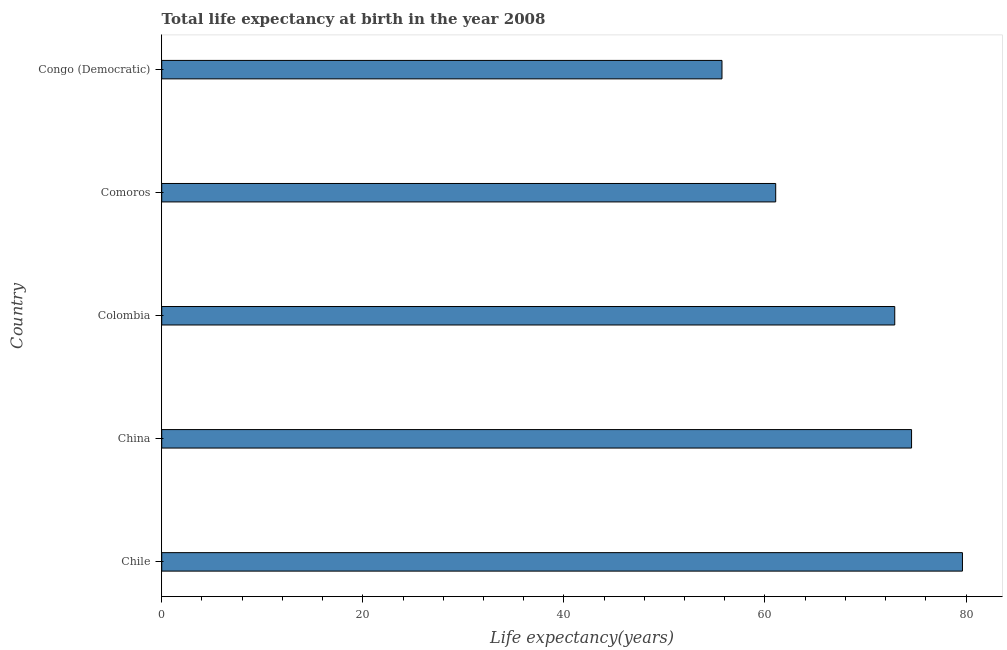What is the title of the graph?
Your response must be concise. Total life expectancy at birth in the year 2008. What is the label or title of the X-axis?
Make the answer very short. Life expectancy(years). What is the life expectancy at birth in Chile?
Keep it short and to the point. 79.64. Across all countries, what is the maximum life expectancy at birth?
Your answer should be compact. 79.64. Across all countries, what is the minimum life expectancy at birth?
Offer a terse response. 55.72. In which country was the life expectancy at birth maximum?
Your answer should be very brief. Chile. In which country was the life expectancy at birth minimum?
Your response must be concise. Congo (Democratic). What is the sum of the life expectancy at birth?
Provide a succinct answer. 343.92. What is the difference between the life expectancy at birth in China and Colombia?
Offer a very short reply. 1.67. What is the average life expectancy at birth per country?
Make the answer very short. 68.78. What is the median life expectancy at birth?
Provide a short and direct response. 72.91. In how many countries, is the life expectancy at birth greater than 68 years?
Offer a very short reply. 3. What is the ratio of the life expectancy at birth in Chile to that in Comoros?
Provide a short and direct response. 1.3. Is the difference between the life expectancy at birth in Colombia and Congo (Democratic) greater than the difference between any two countries?
Offer a terse response. No. What is the difference between the highest and the second highest life expectancy at birth?
Your answer should be compact. 5.06. What is the difference between the highest and the lowest life expectancy at birth?
Make the answer very short. 23.92. How many bars are there?
Ensure brevity in your answer.  5. Are all the bars in the graph horizontal?
Offer a terse response. Yes. What is the Life expectancy(years) of Chile?
Your answer should be compact. 79.64. What is the Life expectancy(years) of China?
Keep it short and to the point. 74.58. What is the Life expectancy(years) in Colombia?
Your response must be concise. 72.91. What is the Life expectancy(years) in Comoros?
Offer a terse response. 61.07. What is the Life expectancy(years) in Congo (Democratic)?
Give a very brief answer. 55.72. What is the difference between the Life expectancy(years) in Chile and China?
Give a very brief answer. 5.06. What is the difference between the Life expectancy(years) in Chile and Colombia?
Your answer should be very brief. 6.73. What is the difference between the Life expectancy(years) in Chile and Comoros?
Provide a succinct answer. 18.57. What is the difference between the Life expectancy(years) in Chile and Congo (Democratic)?
Your answer should be very brief. 23.92. What is the difference between the Life expectancy(years) in China and Colombia?
Ensure brevity in your answer.  1.67. What is the difference between the Life expectancy(years) in China and Comoros?
Give a very brief answer. 13.51. What is the difference between the Life expectancy(years) in China and Congo (Democratic)?
Give a very brief answer. 18.86. What is the difference between the Life expectancy(years) in Colombia and Comoros?
Offer a very short reply. 11.84. What is the difference between the Life expectancy(years) in Colombia and Congo (Democratic)?
Ensure brevity in your answer.  17.18. What is the difference between the Life expectancy(years) in Comoros and Congo (Democratic)?
Offer a terse response. 5.34. What is the ratio of the Life expectancy(years) in Chile to that in China?
Keep it short and to the point. 1.07. What is the ratio of the Life expectancy(years) in Chile to that in Colombia?
Offer a terse response. 1.09. What is the ratio of the Life expectancy(years) in Chile to that in Comoros?
Ensure brevity in your answer.  1.3. What is the ratio of the Life expectancy(years) in Chile to that in Congo (Democratic)?
Provide a short and direct response. 1.43. What is the ratio of the Life expectancy(years) in China to that in Colombia?
Provide a short and direct response. 1.02. What is the ratio of the Life expectancy(years) in China to that in Comoros?
Give a very brief answer. 1.22. What is the ratio of the Life expectancy(years) in China to that in Congo (Democratic)?
Provide a short and direct response. 1.34. What is the ratio of the Life expectancy(years) in Colombia to that in Comoros?
Make the answer very short. 1.19. What is the ratio of the Life expectancy(years) in Colombia to that in Congo (Democratic)?
Keep it short and to the point. 1.31. What is the ratio of the Life expectancy(years) in Comoros to that in Congo (Democratic)?
Your response must be concise. 1.1. 